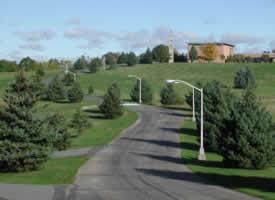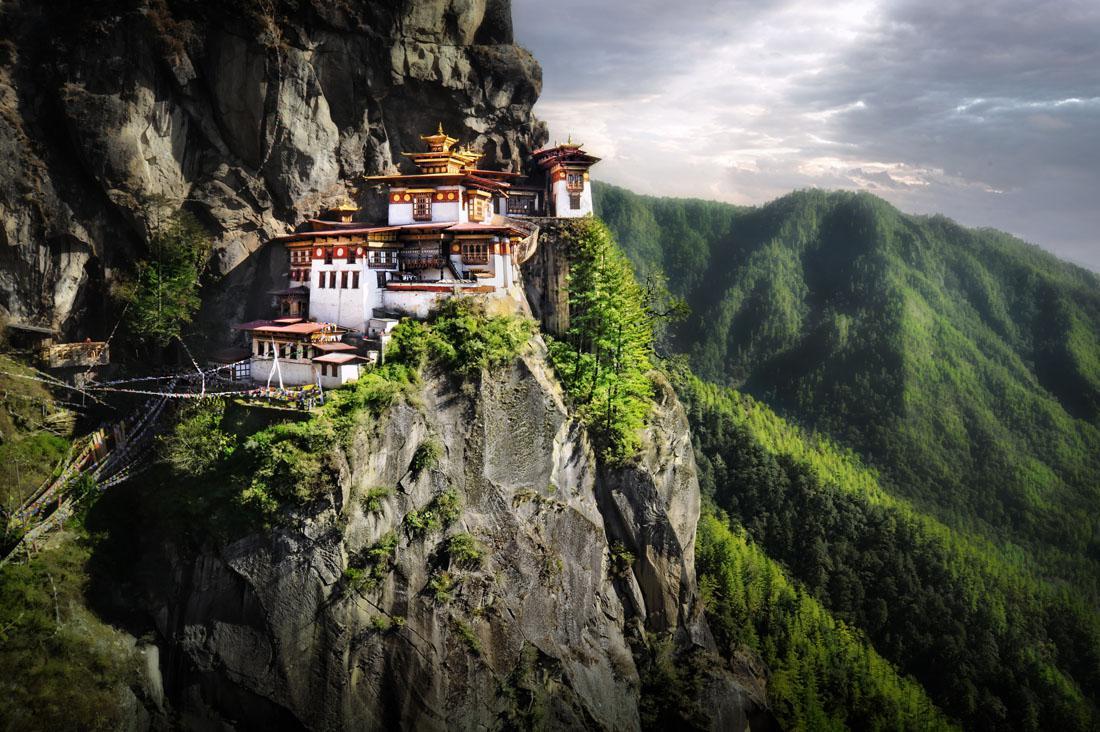The first image is the image on the left, the second image is the image on the right. Assess this claim about the two images: "At least one person is posing while wearing a robe.". Correct or not? Answer yes or no. No. The first image is the image on the left, the second image is the image on the right. Analyze the images presented: Is the assertion "At least one image shows a person with a shaved head wearing a solid-colored robe." valid? Answer yes or no. No. 